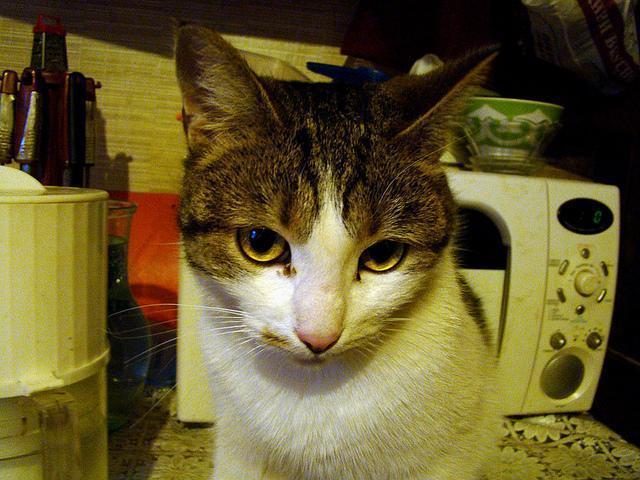How many microwaves are in the picture?
Give a very brief answer. 1. 